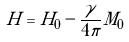<formula> <loc_0><loc_0><loc_500><loc_500>H = H _ { 0 } - \frac { \gamma } { 4 \pi } M _ { 0 }</formula> 